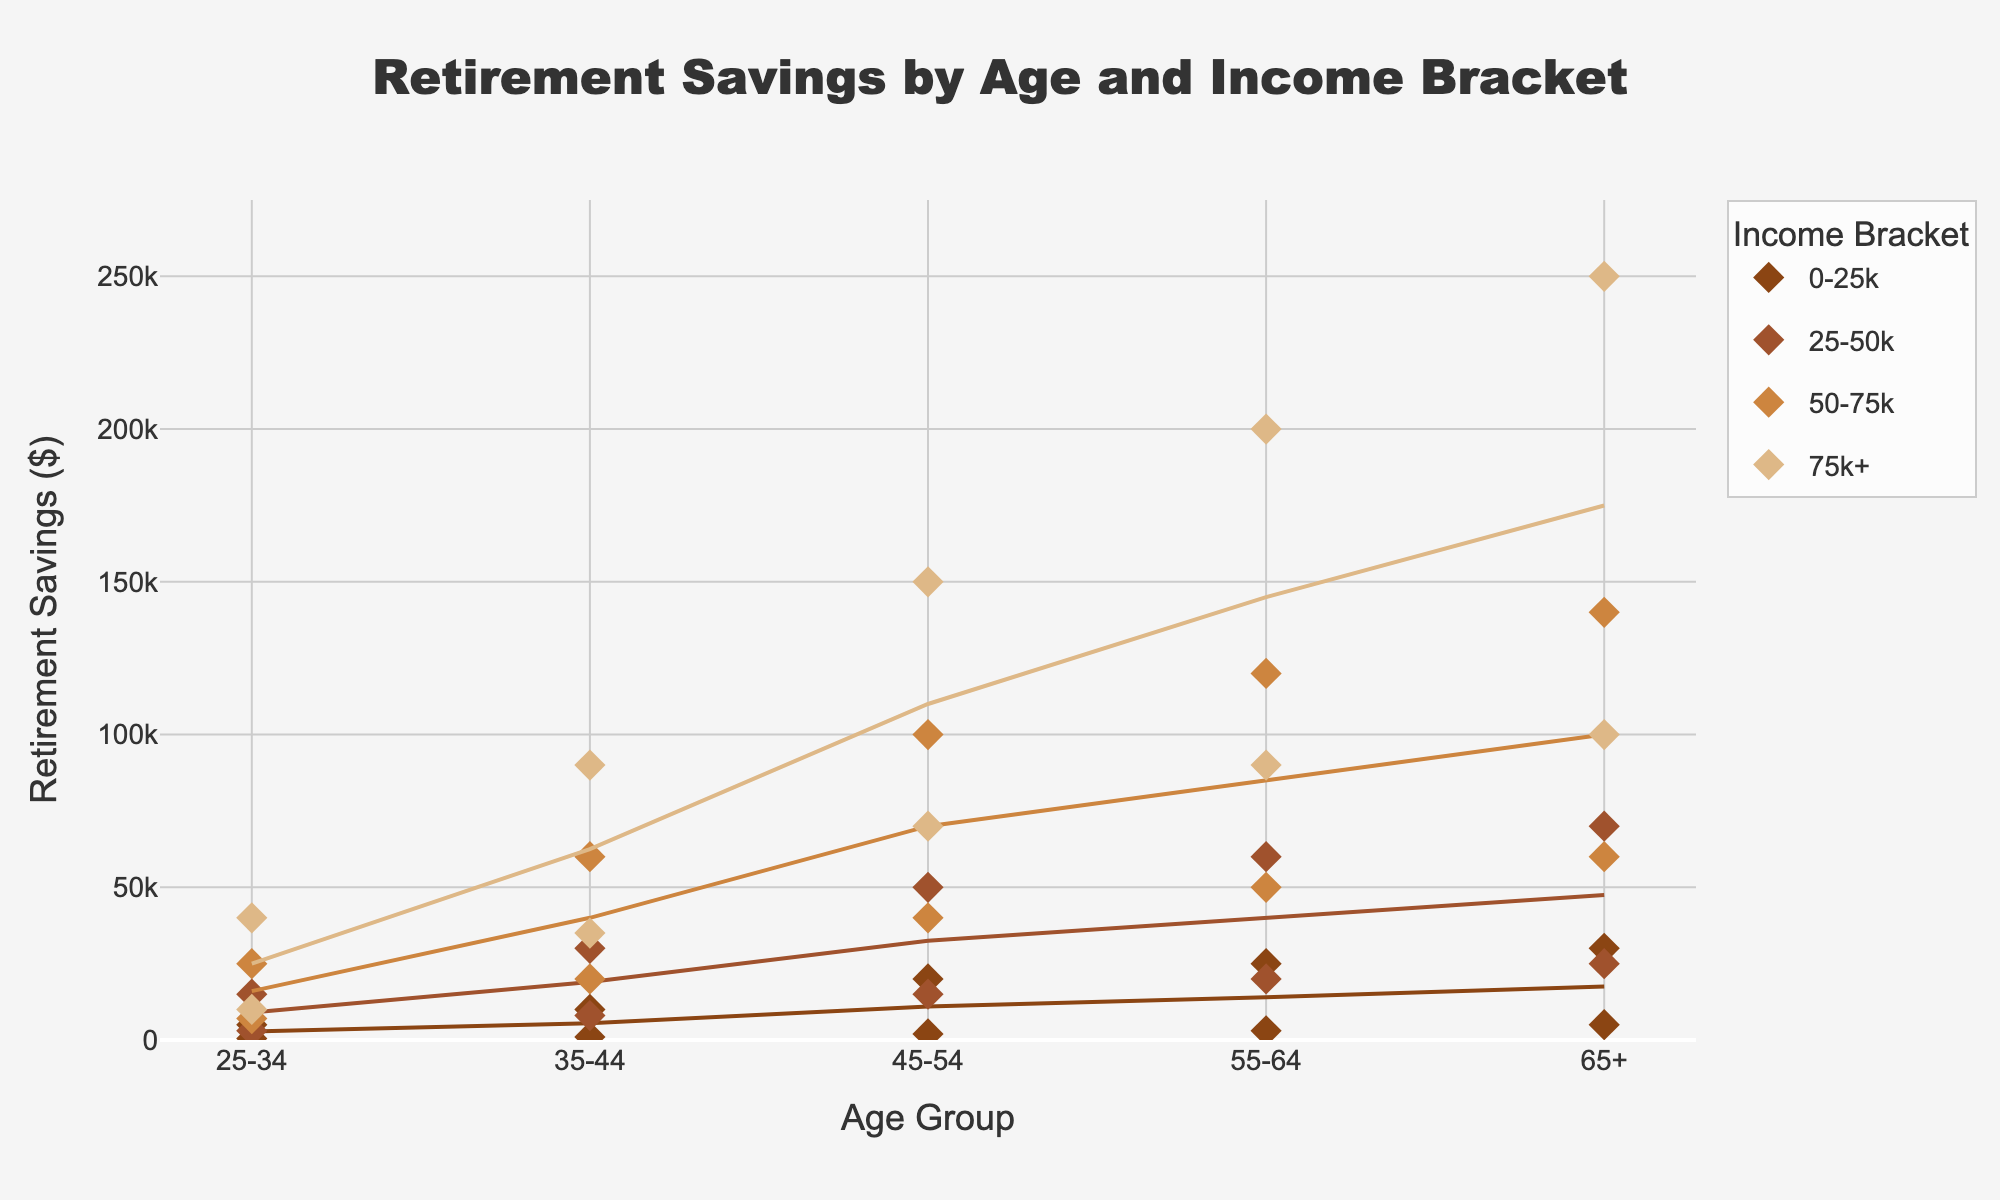What's the title of the figure? The title is usually at the top center of the figure, and it helps describe what the plot represents.
Answer: Retirement Savings by Age and Income Bracket What is the range of retirement savings for the age group 55-64 with an income bracket of 75k+? Identify the data points for the specific age group and income bracket, then look at the lower and upper bounds on the y-axis. The lower bound for 55-64 with an income of 75k+ is 90,000, and the upper bound is 200,000.
Answer: $90,000 to $200,000 Which income bracket has the highest upper bound of retirement savings in the age group 45-54? Focus on the age group 45-54 and compare the upper bounds of different income brackets. The income bracket with the highest upper bound is 75k+ with 150,000.
Answer: 75k+ What is the difference in the upper bound of retirement savings between the income brackets 25-50k and 50-75k for the age group 25-34? For the age group 25-34, look up the upper bounds for the income brackets 25-50k and 50-75k: 15,000 and 25,000 respectively. Subtract the upper bound of 25-50k from 50-75k to get the difference.
Answer: 10,000 How do the lower bounds of retirement savings compare between the age group 35-44 and 45-54 for the income bracket 0-25k? Look at the lower bounds for the age groups 35-44 and 45-54 in the 0-25k income bracket: 1,000 and 2,000 respectively. The lower bound for 45-54 is higher by 1,000.
Answer: The lower bound for 45-54 is higher What is the average upper bound retirement savings for all income brackets in the age group 65+? Calculate the sum of the upper bounds for all income brackets in the age group 65+ and divide by the number of brackets. The sums are 30,000 + 70,000 + 140,000 + 250,000 = 490,000, and there are 4 brackets, so the average is 490,000 / 4.
Answer: 122,500 Which age and income group has the lowest lower bound in retirement savings, and what is it? Scan through all age and income groups to find the lowest lower bound. The lowest lower bound is for 25-34 in the 0-25k income bracket, which is 500.
Answer: 25-34, 0-25k, $500 